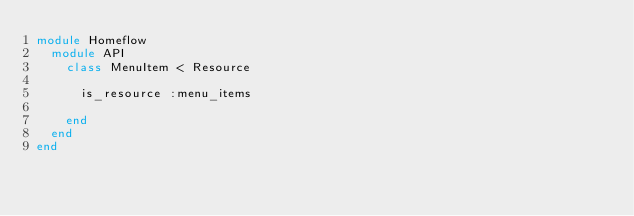<code> <loc_0><loc_0><loc_500><loc_500><_Ruby_>module Homeflow
  module API
    class MenuItem < Resource

      is_resource :menu_items

    end
  end
end
</code> 